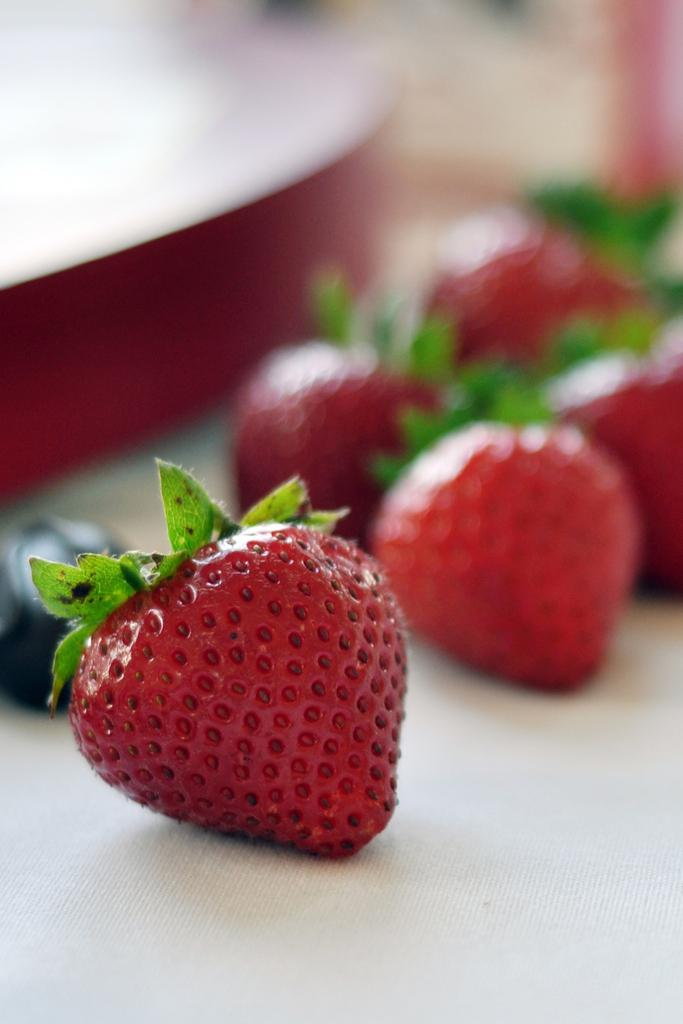What type of fruit is present in the image? There are strawberries in the image. Can you describe the background of the image? The background of the image is blurred. What type of manager is depicted in the image? There is no manager present in the image; it only features strawberries and a blurred background. 